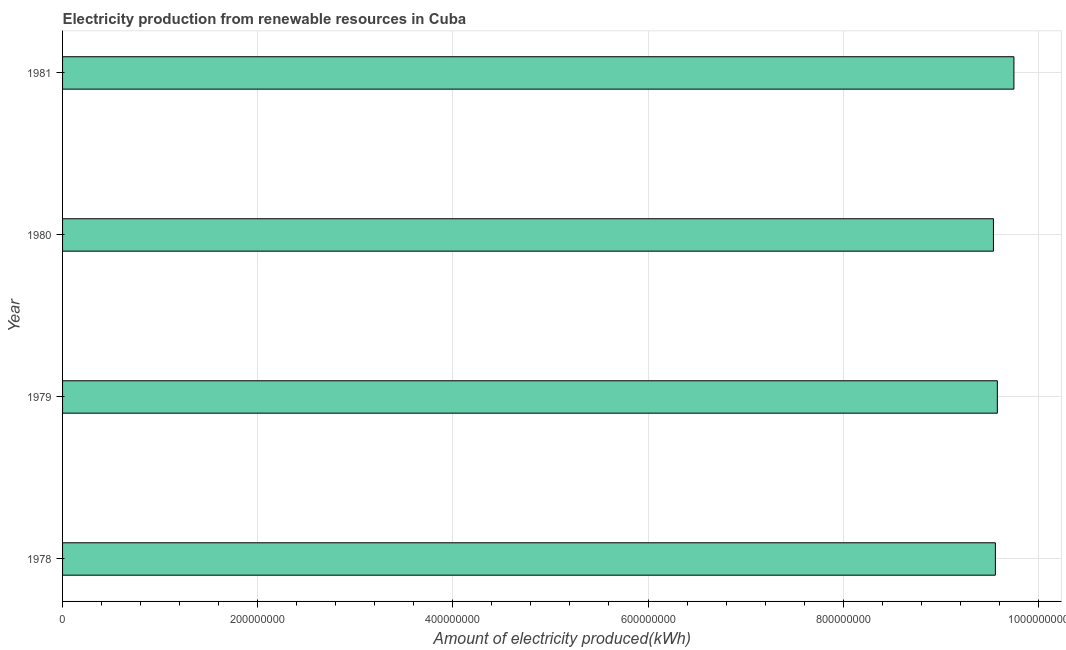What is the title of the graph?
Your answer should be very brief. Electricity production from renewable resources in Cuba. What is the label or title of the X-axis?
Keep it short and to the point. Amount of electricity produced(kWh). What is the label or title of the Y-axis?
Provide a succinct answer. Year. What is the amount of electricity produced in 1978?
Your answer should be very brief. 9.56e+08. Across all years, what is the maximum amount of electricity produced?
Offer a terse response. 9.75e+08. Across all years, what is the minimum amount of electricity produced?
Offer a terse response. 9.54e+08. In which year was the amount of electricity produced maximum?
Ensure brevity in your answer.  1981. In which year was the amount of electricity produced minimum?
Your answer should be compact. 1980. What is the sum of the amount of electricity produced?
Give a very brief answer. 3.84e+09. What is the difference between the amount of electricity produced in 1979 and 1981?
Your answer should be very brief. -1.70e+07. What is the average amount of electricity produced per year?
Your response must be concise. 9.61e+08. What is the median amount of electricity produced?
Provide a succinct answer. 9.57e+08. What is the ratio of the amount of electricity produced in 1978 to that in 1979?
Provide a short and direct response. 1. What is the difference between the highest and the second highest amount of electricity produced?
Give a very brief answer. 1.70e+07. Is the sum of the amount of electricity produced in 1980 and 1981 greater than the maximum amount of electricity produced across all years?
Your answer should be compact. Yes. What is the difference between the highest and the lowest amount of electricity produced?
Give a very brief answer. 2.10e+07. Are all the bars in the graph horizontal?
Ensure brevity in your answer.  Yes. How many years are there in the graph?
Provide a short and direct response. 4. What is the difference between two consecutive major ticks on the X-axis?
Your response must be concise. 2.00e+08. What is the Amount of electricity produced(kWh) in 1978?
Provide a short and direct response. 9.56e+08. What is the Amount of electricity produced(kWh) in 1979?
Your answer should be very brief. 9.58e+08. What is the Amount of electricity produced(kWh) of 1980?
Ensure brevity in your answer.  9.54e+08. What is the Amount of electricity produced(kWh) of 1981?
Your answer should be very brief. 9.75e+08. What is the difference between the Amount of electricity produced(kWh) in 1978 and 1981?
Your answer should be very brief. -1.90e+07. What is the difference between the Amount of electricity produced(kWh) in 1979 and 1980?
Provide a succinct answer. 4.00e+06. What is the difference between the Amount of electricity produced(kWh) in 1979 and 1981?
Give a very brief answer. -1.70e+07. What is the difference between the Amount of electricity produced(kWh) in 1980 and 1981?
Give a very brief answer. -2.10e+07. What is the ratio of the Amount of electricity produced(kWh) in 1980 to that in 1981?
Give a very brief answer. 0.98. 